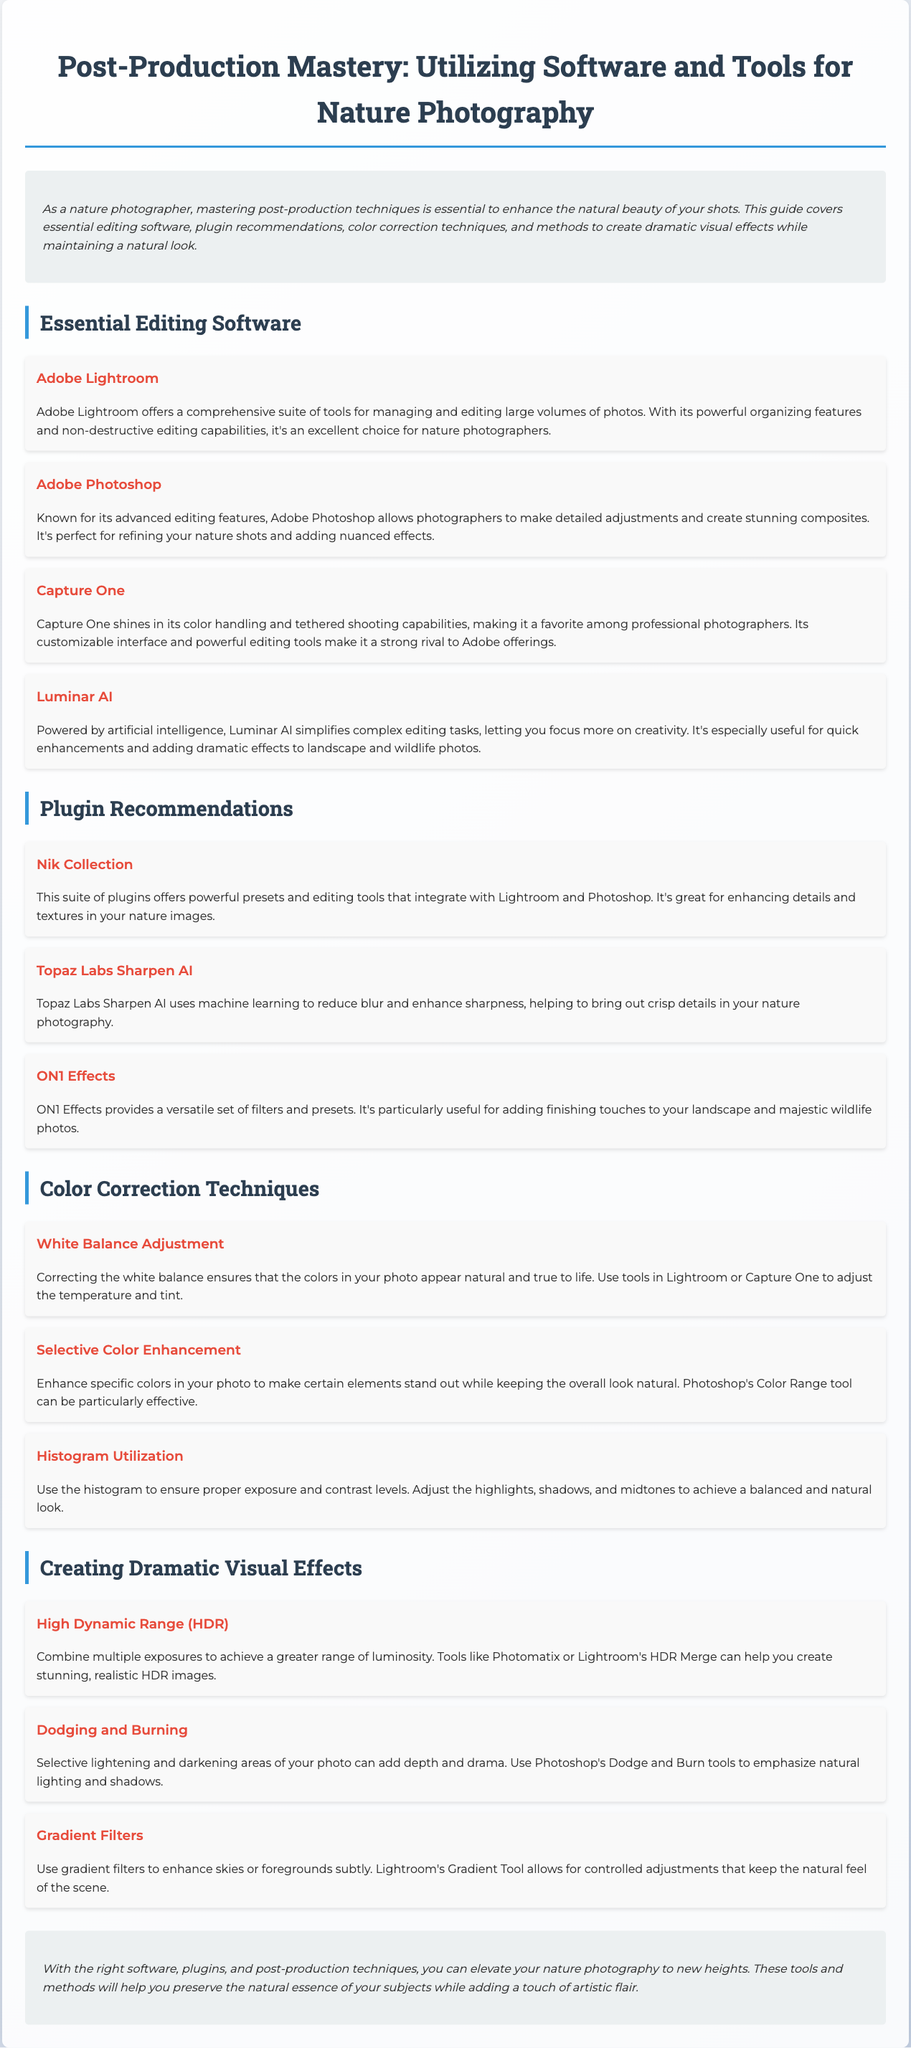What is one of the essential editing software mentioned? The document lists several essential editing software options, including Adobe Lightroom, Adobe Photoshop, and Capture One.
Answer: Adobe Lightroom Which plugin offers powerful presets and editing tools? The document states that the Nik Collection is a suite of plugins that integrates with Lightroom and Photoshop, offering powerful presets and editing tools.
Answer: Nik Collection What technique is used for adjusting colors in specific areas of a photo? The document describes Selective Color Enhancement as a technique to enhance specific colors in a photo while maintaining a natural look.
Answer: Selective Color Enhancement What is the purpose of histogram utilization in photo editing? The histogram is utilized in the document to ensure proper exposure and contrast levels in photography.
Answer: Proper exposure What editing software is known for its artificial intelligence capabilities? The document mentions Luminar AI as an editing software that is powered by artificial intelligence to simplify complex editing tasks.
Answer: Luminar AI What does HDR stand for in the context of photography? The document explains that HDR is an abbreviation for High Dynamic Range, which combines multiple exposures for a greater range of luminosity.
Answer: High Dynamic Range Which technique can add depth and drama to a photo? The document outlines Dodging and Burning as a technique for selectively lightening and darkening areas of a photo to add depth and drama.
Answer: Dodging and Burning What adjustments can be made using Lightroom's Gradient Tool? The document explains that the Gradient Tool allows for controlled adjustments to enhance skies or foregrounds subtly while keeping the natural feel of the scene.
Answer: Enhance skies What type of imaging software is Capture One categorized as? The document states that Capture One shines in its color handling and tethered shooting capabilities, making it a favorite among professional photographers.
Answer: Color handling software 